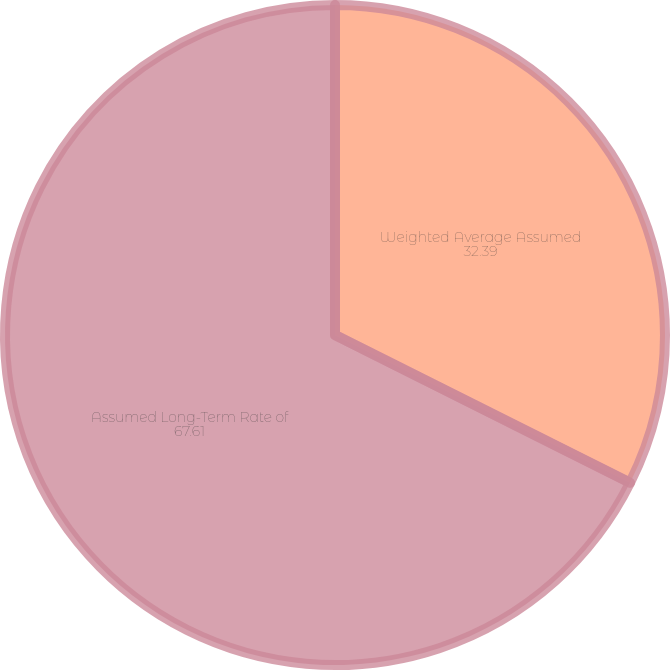Convert chart. <chart><loc_0><loc_0><loc_500><loc_500><pie_chart><fcel>Weighted Average Assumed<fcel>Assumed Long-Term Rate of<nl><fcel>32.39%<fcel>67.61%<nl></chart> 